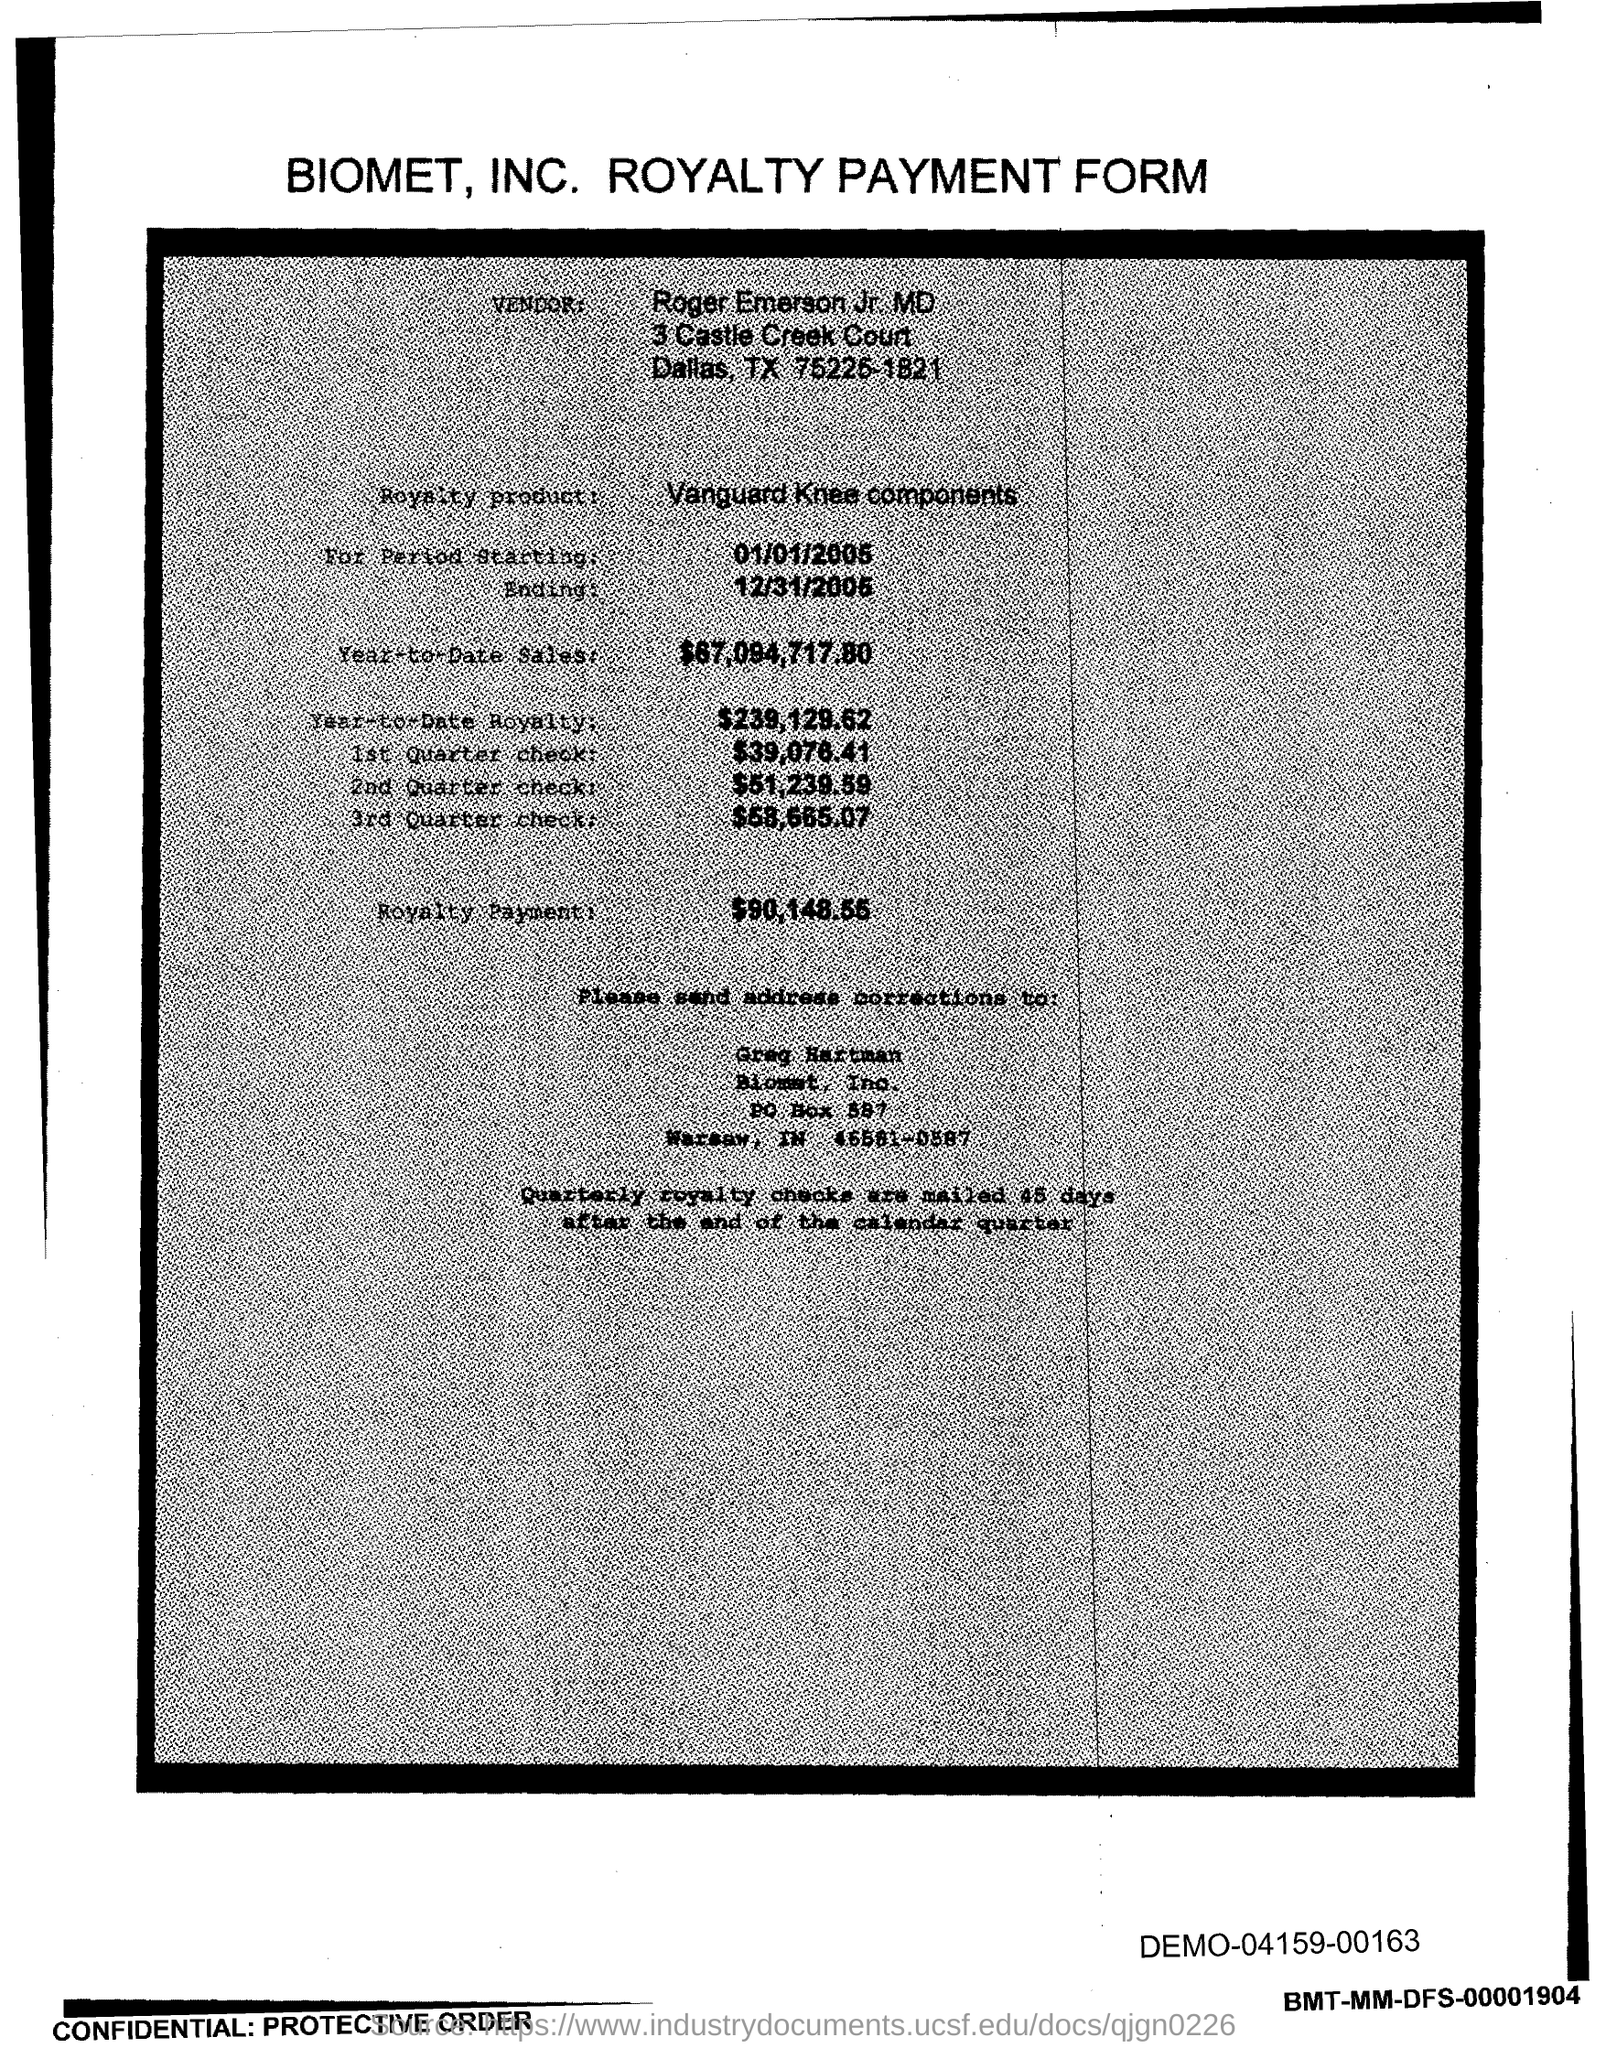What is the vendor name given in the form?
Give a very brief answer. Roger Emerson Jr. MD. What is the royalty payment of the product mentioned in the form?
Your answer should be very brief. $90,148.55. What is the start date of the royalty period?
Give a very brief answer. 01/01/2005. What is the end date of the royalty period?
Make the answer very short. 12/31/2005. What is the royalty product given in the form?
Provide a succinct answer. Vanguard Knee components. What is the Year-to-Date Sales of the royalty product?
Your answer should be very brief. $67,094,717.80. What is the Year-to-Date royalty of the product?
Your answer should be very brief. $239,129.62. What is the amount of 1st quarter check mentioned in the form?
Make the answer very short. $39,076.41. 